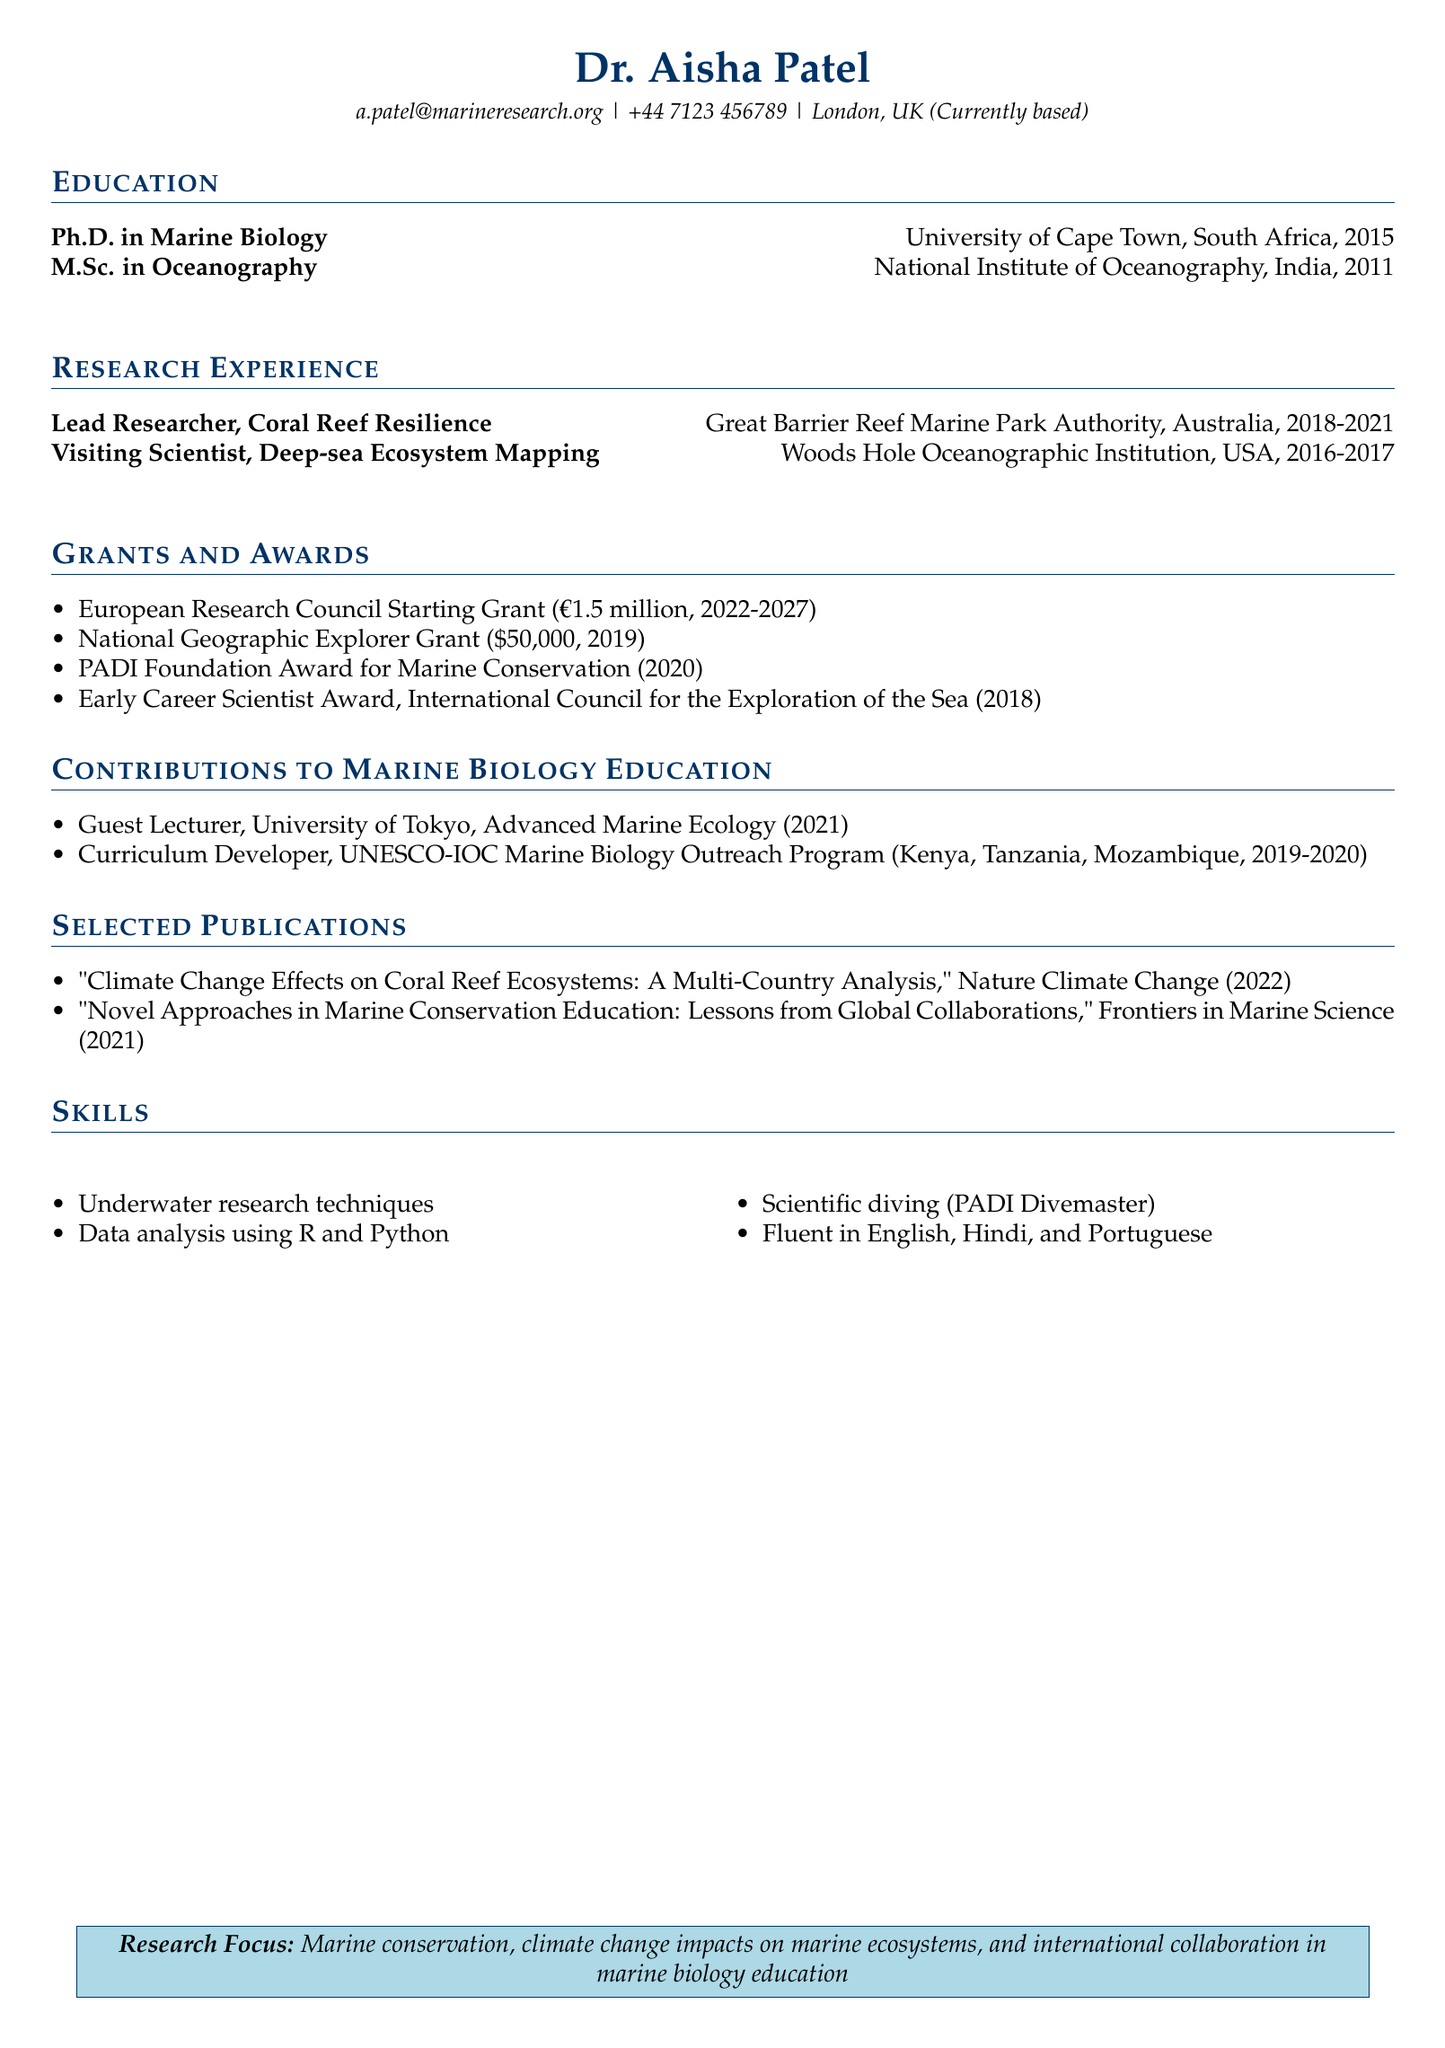What is the highest grant amount listed? The highest grant amount listed is €1.5 million from the European Research Council Starting Grant.
Answer: €1.5 million In which year did Dr. Aisha Patel complete her Ph.D.? The year Dr. Aisha Patel completed her Ph.D. is mentioned in the education section.
Answer: 2015 What is the name of the project during Dr. Patel's time as a Visiting Scientist? The project name is provided in the research section of the document.
Answer: Deep-sea Ecosystem Mapping Which award did Dr. Patel receive in 2020? The specific award given in 2020 can be found in the awards section.
Answer: PADI Foundation Award for Marine Conservation How many countries are mentioned in relation to the Marine Biology Outreach Program? The number of countries involved is stated in the contributions section.
Answer: 3 What was the focus of Dr. Patel's research project from 2018 to 2021? The research project title indicates the focus and is found in the research experience section.
Answer: Coral Reef Resilience in the Face of Climate Change Which institution awarded Dr. Patel the Early Career Scientist Award? The institution is listed in the awards section.
Answer: International Council for the Exploration of the Sea (ICES) What is the main research focus stated in the document? The main research focus is described in the last section of the document.
Answer: Marine conservation, climate change impacts on marine ecosystems, and international collaboration in marine biology education 